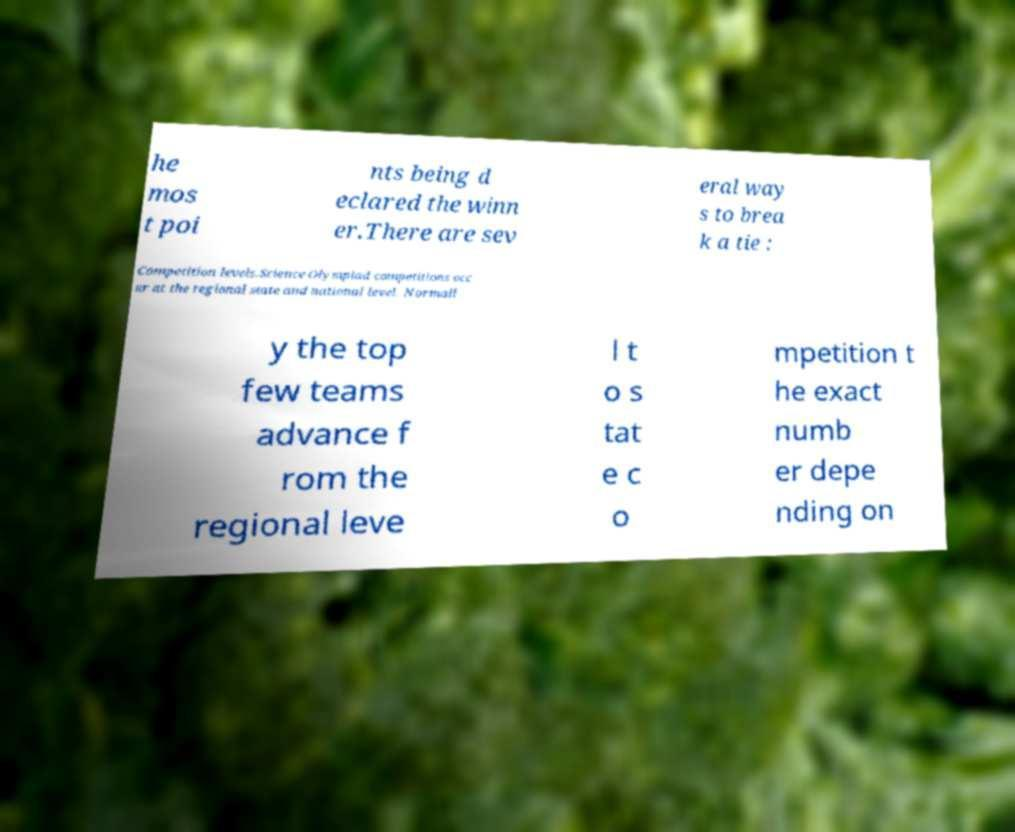There's text embedded in this image that I need extracted. Can you transcribe it verbatim? he mos t poi nts being d eclared the winn er.There are sev eral way s to brea k a tie : Competition levels.Science Olympiad competitions occ ur at the regional state and national level. Normall y the top few teams advance f rom the regional leve l t o s tat e c o mpetition t he exact numb er depe nding on 